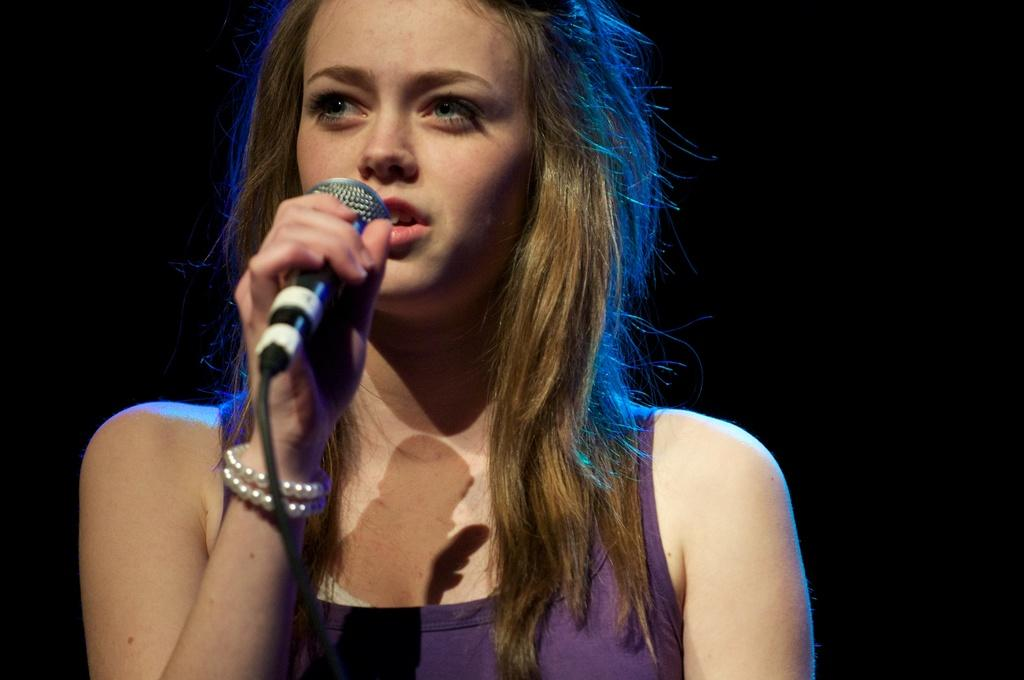Who is the main subject in the image? There is a woman in the image. What is the woman holding in her hand? The woman is holding a mic in her hand. What is the woman doing in the image? The woman is singing. What can be observed about the background of the image? The background of the image is dark. What type of brick is being used as a prop in the image? There is no brick present in the image. 